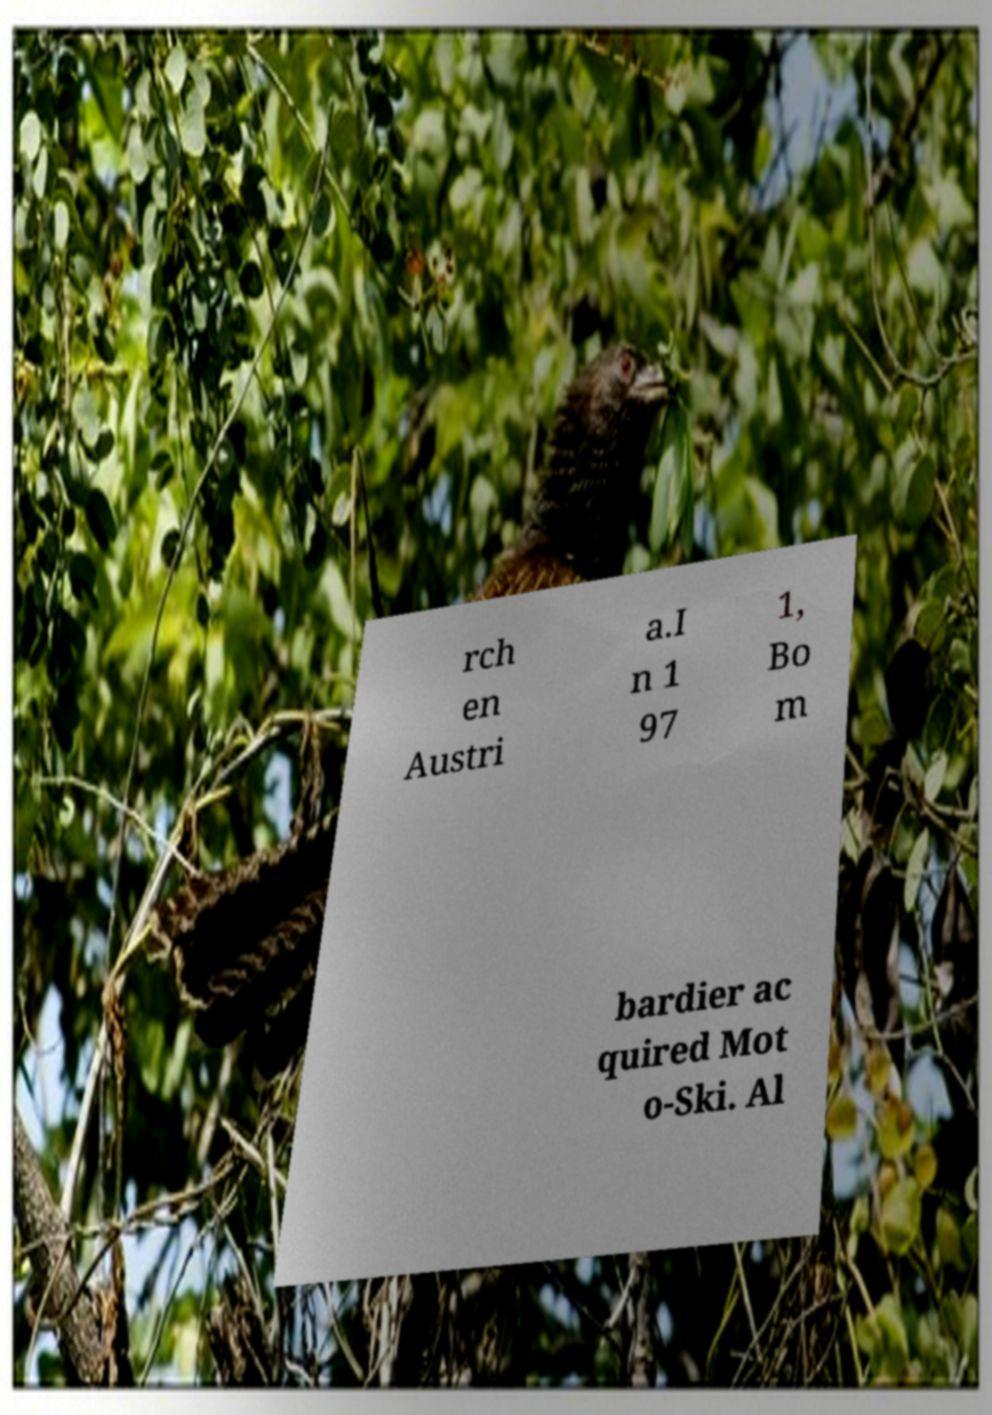I need the written content from this picture converted into text. Can you do that? rch en Austri a.I n 1 97 1, Bo m bardier ac quired Mot o-Ski. Al 